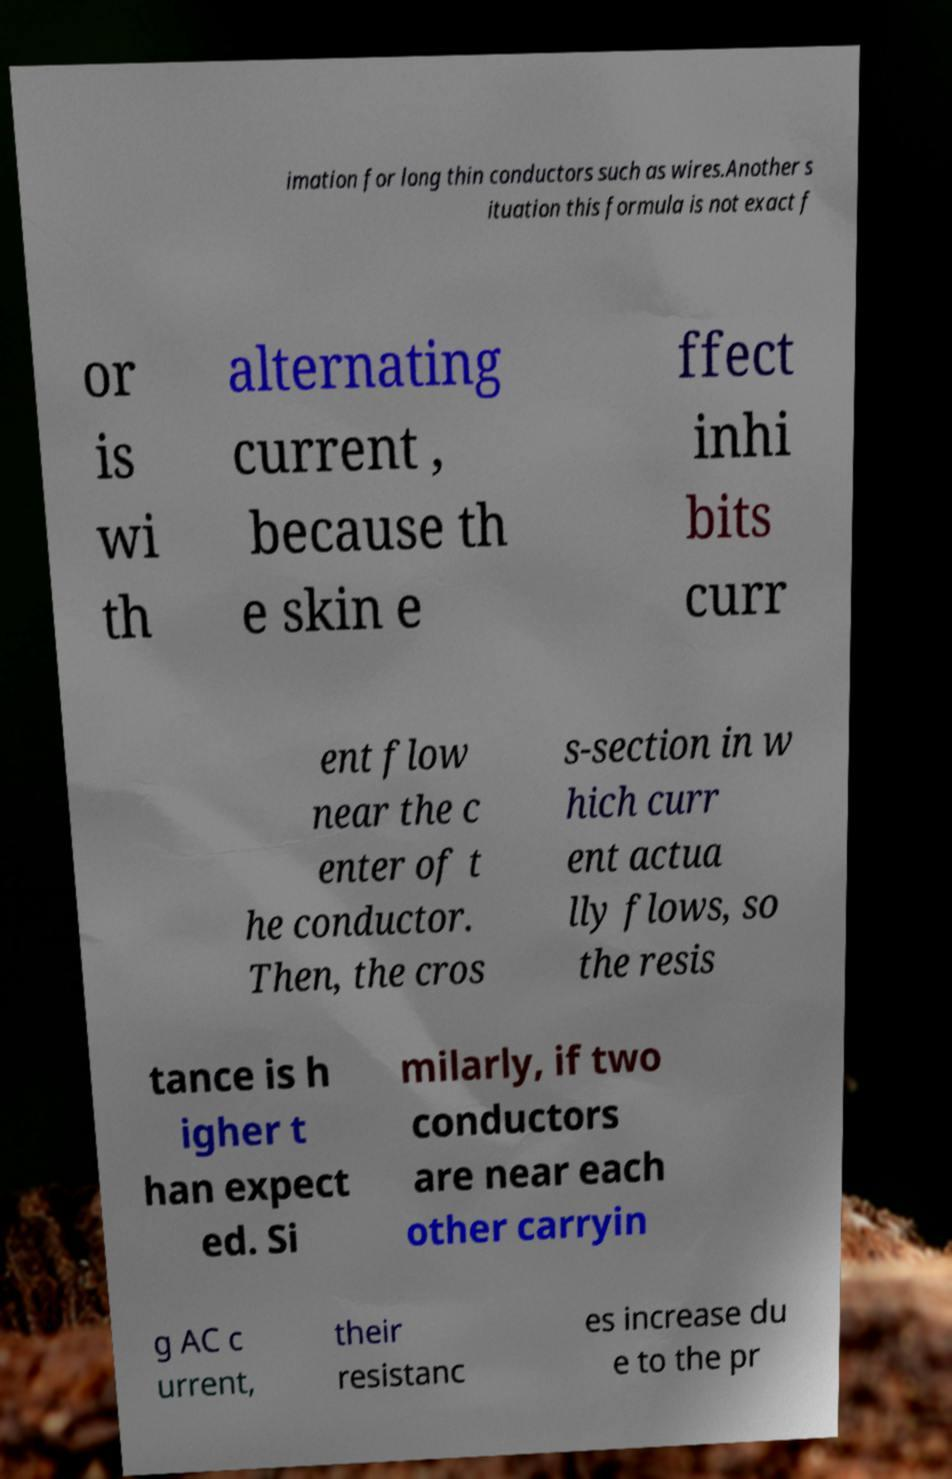I need the written content from this picture converted into text. Can you do that? imation for long thin conductors such as wires.Another s ituation this formula is not exact f or is wi th alternating current , because th e skin e ffect inhi bits curr ent flow near the c enter of t he conductor. Then, the cros s-section in w hich curr ent actua lly flows, so the resis tance is h igher t han expect ed. Si milarly, if two conductors are near each other carryin g AC c urrent, their resistanc es increase du e to the pr 